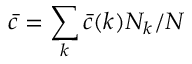<formula> <loc_0><loc_0><loc_500><loc_500>\bar { c } = \sum _ { k } \bar { c } ( k ) N _ { k } / N</formula> 